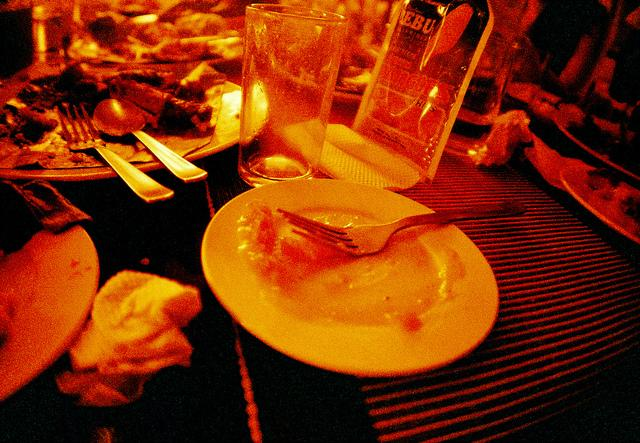Why would someone sit at this table? Please explain your reasoning. to eat. It's obvious that someone has dined here. 